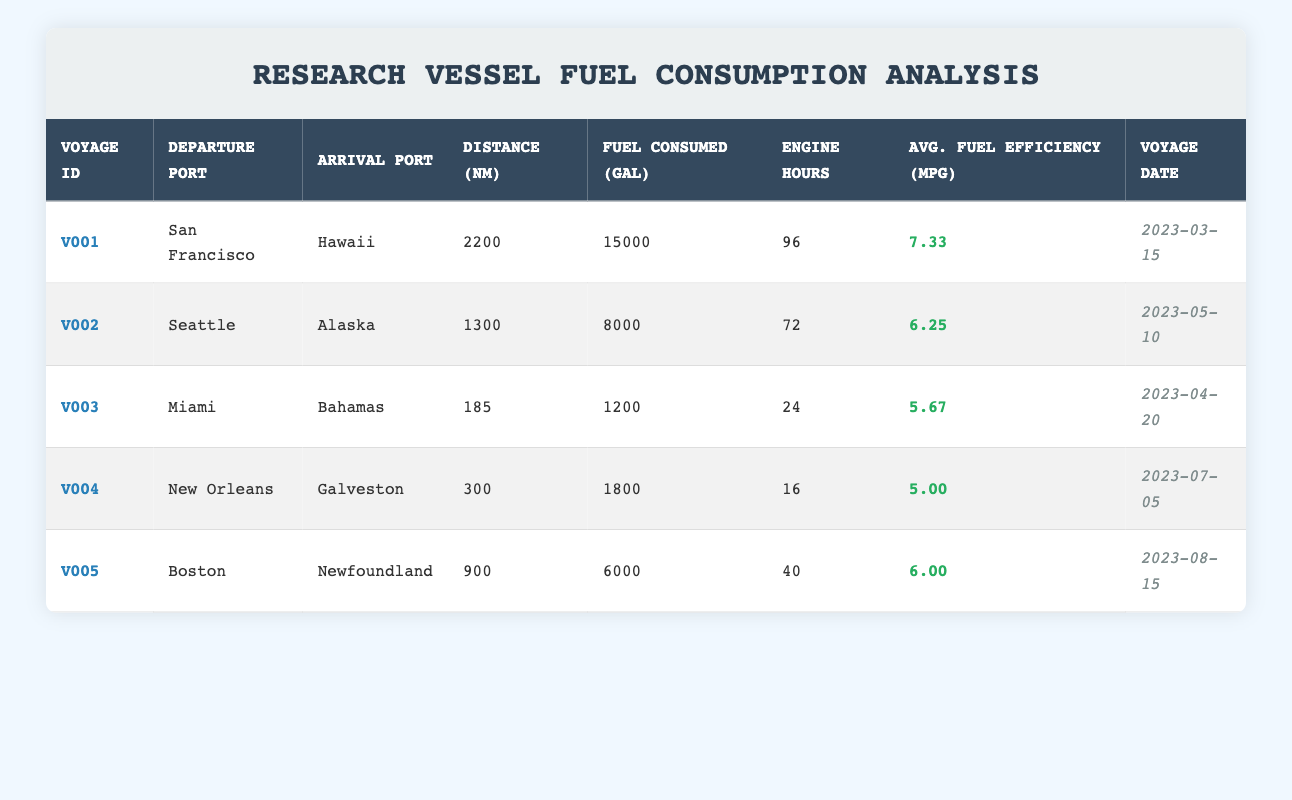What is the average fuel efficiency for Voyage V002? From the table, the average fuel efficiency for Voyage V002 is listed as 6.25 MPG. Since no calculations are needed (as the value is directly provided), the answer is straightforward.
Answer: 6.25 MPG How many gallons of fuel were consumed in Voyage V004? According to the table, Voyage V004 consumed 1,800 gallons of fuel. This value is directly taken from the table without any calculations.
Answer: 1,800 gallons Which voyage had the highest distance traveled? Looking through the table, Voyage V001 has the highest distance at 2,200 nautical miles. We compare all distances: V001 (2,200), V002 (1,300), V003 (185), V004 (300), V005 (900) and confirm that V001 is the highest.
Answer: V001 What is the total fuel consumed for Voyages V003 and V005? The fuel consumed for V003 is 1,200 gallons and for V005 is 6,000 gallons. We add these values together: 1,200 + 6,000 = 7,200 gallons. Hence, after summing both voyages, we find the total fuel consumed.
Answer: 7,200 gallons Did Voyage V001 take longer to complete than Voyage V004? Analyzing the engine operating hours from the data, V001 took 96 hours and V004 took 16 hours. Comparing the two shows that V001 took much longer than V004, providing a clear yes statement.
Answer: Yes What is the average distance traveled across all voyages? To find the average distance, we first sum the distances of all voyages: 2,200 (V001) + 1,300 (V002) + 185 (V003) + 300 (V004) + 900 (V005) = 4,885 nautical miles. Since there are 5 voyages, we divide: 4,885 / 5 = 977 nautical miles. We perform these calculations in steps to reach the average.
Answer: 977 nautical miles Was the average fuel efficiency of V005 greater than that of V003? The average fuel efficiency for V005 is 6.00 MPG and for V003 is 5.67 MPG. Comparing these two values confirms that 6.00 is indeed greater than 5.67. Thus, the statement is true.
Answer: Yes How many total engine hours were recorded for all voyages combined? Summing the engine operating hours: 96 (V001) + 72 (V002) + 24 (V003) + 16 (V004) + 40 (V005) gives us a total of 96 + 72 + 24 + 16 + 40 = 248 hours. This simple arithmetic results in the total operating hours across all voyages.
Answer: 248 hours What date did the voyage with the highest fuel consumption take place? We see that V001 has the highest fuel consumption of 15,000 gallons. The corresponding voyage date for V001 is 2023-03-15. So, that is the date we are looking for.
Answer: 2023-03-15 